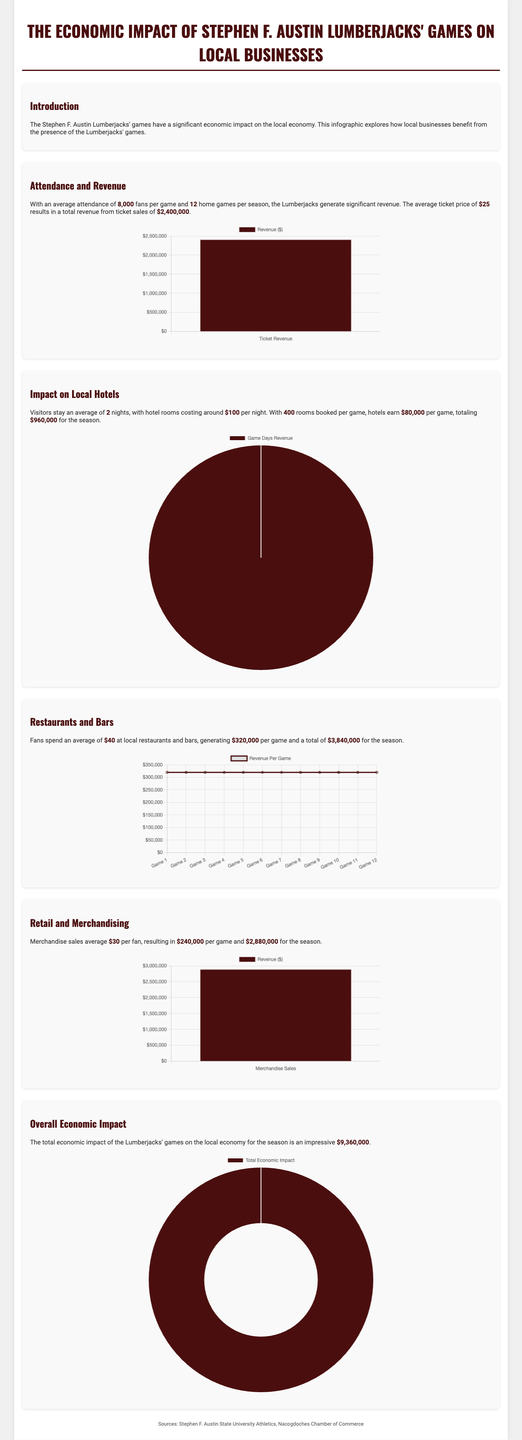What is the average attendance per game? The average attendance per game is stated as 8,000 fans.
Answer: 8,000 fans How many home games are there per season? The document specifies that there are 12 home games each season.
Answer: 12 What is the total revenue from ticket sales? The total revenue from ticket sales is mentioned as $2,400,000.
Answer: $2,400,000 How much do fans spend on average at local restaurants and bars? Fans are reported to spend an average of $40 at local restaurants and bars.
Answer: $40 What is the total economic impact of the Lumberjacks' games on the local economy? The document states that the total economic impact for the season is $9,360,000.
Answer: $9,360,000 How much revenue do local hotels earn per game? Local hotels earn $80,000 per game as mentioned in the document.
Answer: $80,000 How many nights do visitors stay on average? It is noted that visitors stay an average of 2 nights.
Answer: 2 nights What is the average merchandise sales per fan? The average merchandise sales per fan is stated as $30.
Answer: $30 Which revenue source generates the highest total for the season? The highest total revenue source for the season is local restaurants and bars, generating $3,840,000.
Answer: $3,840,000 